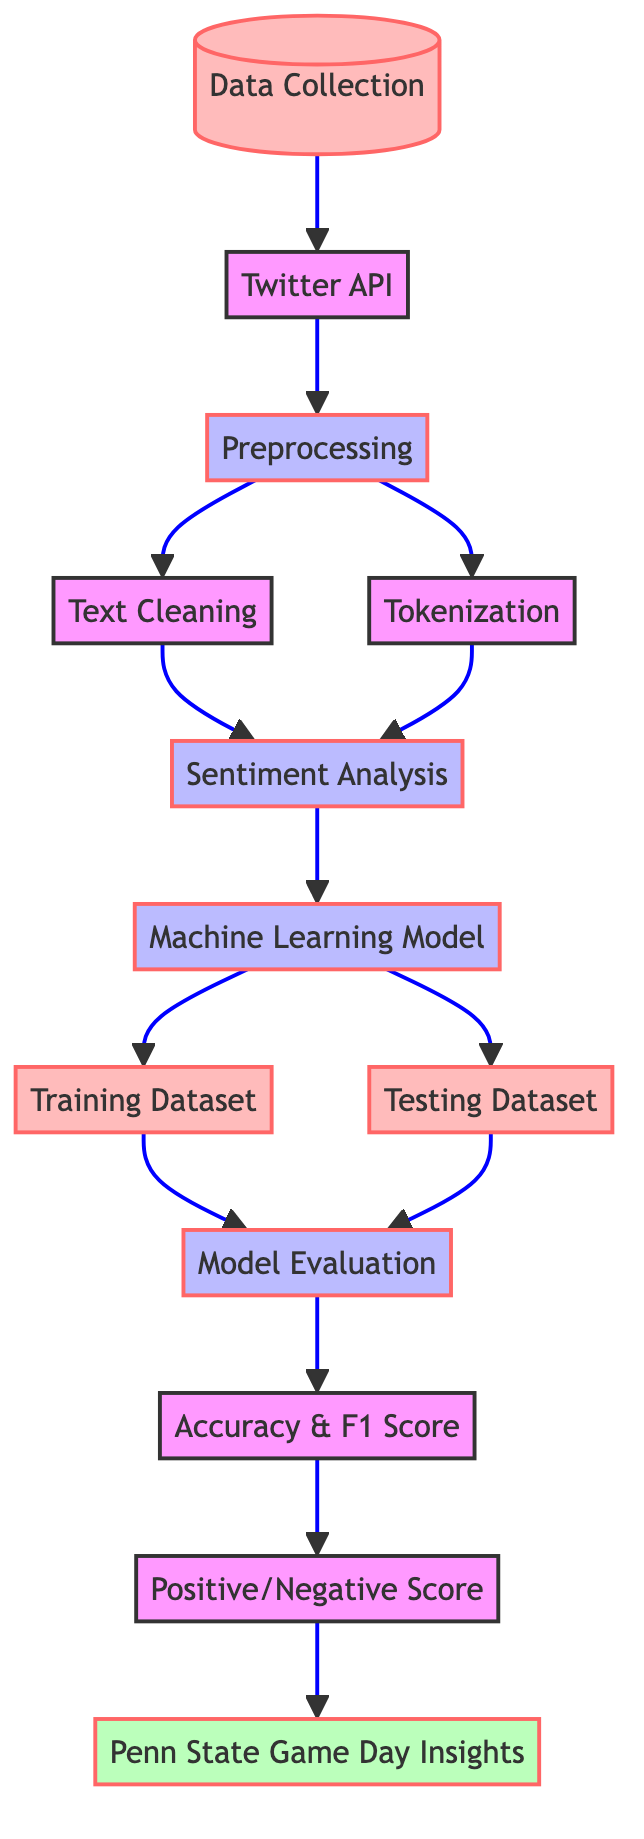What is the first step in the diagram? The first step outlined in the diagram is "Data Collection." This is indicated as the initial node before any other processes begin, representing the starting point of the workflow.
Answer: Data Collection How many processes are shown in the diagram? The diagram contains five process nodes: Preprocessing, Sentiment Analysis, Machine Learning Model, Model Evaluation, and Positive/Negative Score. These processes are defined under the category of processes in the flowchart.
Answer: Five What type of data comes after Data Collection? After "Data Collection," the next node represents the "Twitter API," which signifies the source from which the data is gathered for further analysis.
Answer: Twitter API Which two datasets are involved before Model Evaluation? The two datasets indicated in the diagram that precede "Model Evaluation" are "Training Dataset" and "Testing Dataset." Both datasets are crucial for assessing the model's performance.
Answer: Training Dataset and Testing Dataset What is the last output of the workflow depicted in the diagram? The last output, as shown in the diagram, is "Penn State Game Day Insights." This indicates the final insights generated from the sentiment analysis of tweets, summarizing the overall sentiment.
Answer: Penn State Game Day Insights What relationship exists between Text Cleaning and Tokenization? Both "Text Cleaning" and "Tokenization" are directly linked to the "Preprocessing" step in the workflow. This means that they are sequential processes that need to be completed before conducting sentiment analysis.
Answer: Directly linked to Preprocessing How does the Model Evaluation relate to the subsequent outputs? "Model Evaluation" leads to two outputs, "Accuracy & F1 Score" and "Positive/Negative Score." This indicates that after evaluating the model, these metrics will provide insights into its performance and sentiment categorization.
Answer: Leads to Accuracy & F1 Score and Positive/Negative Score What is indicated by the dashed line linking default class nodes? The dashed line linking the default class nodes signifies the flow of the overall process. It highlights the sequential progression of various stages in the diagram from data collection to final insights.
Answer: Flow of the overall process 